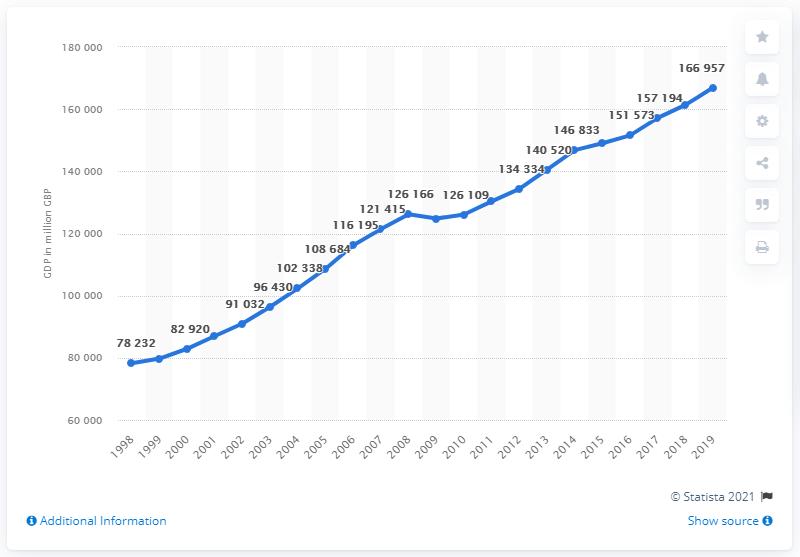Draw attention to some important aspects in this diagram. In 2018, Scotland's gross domestic product was 161,376. 